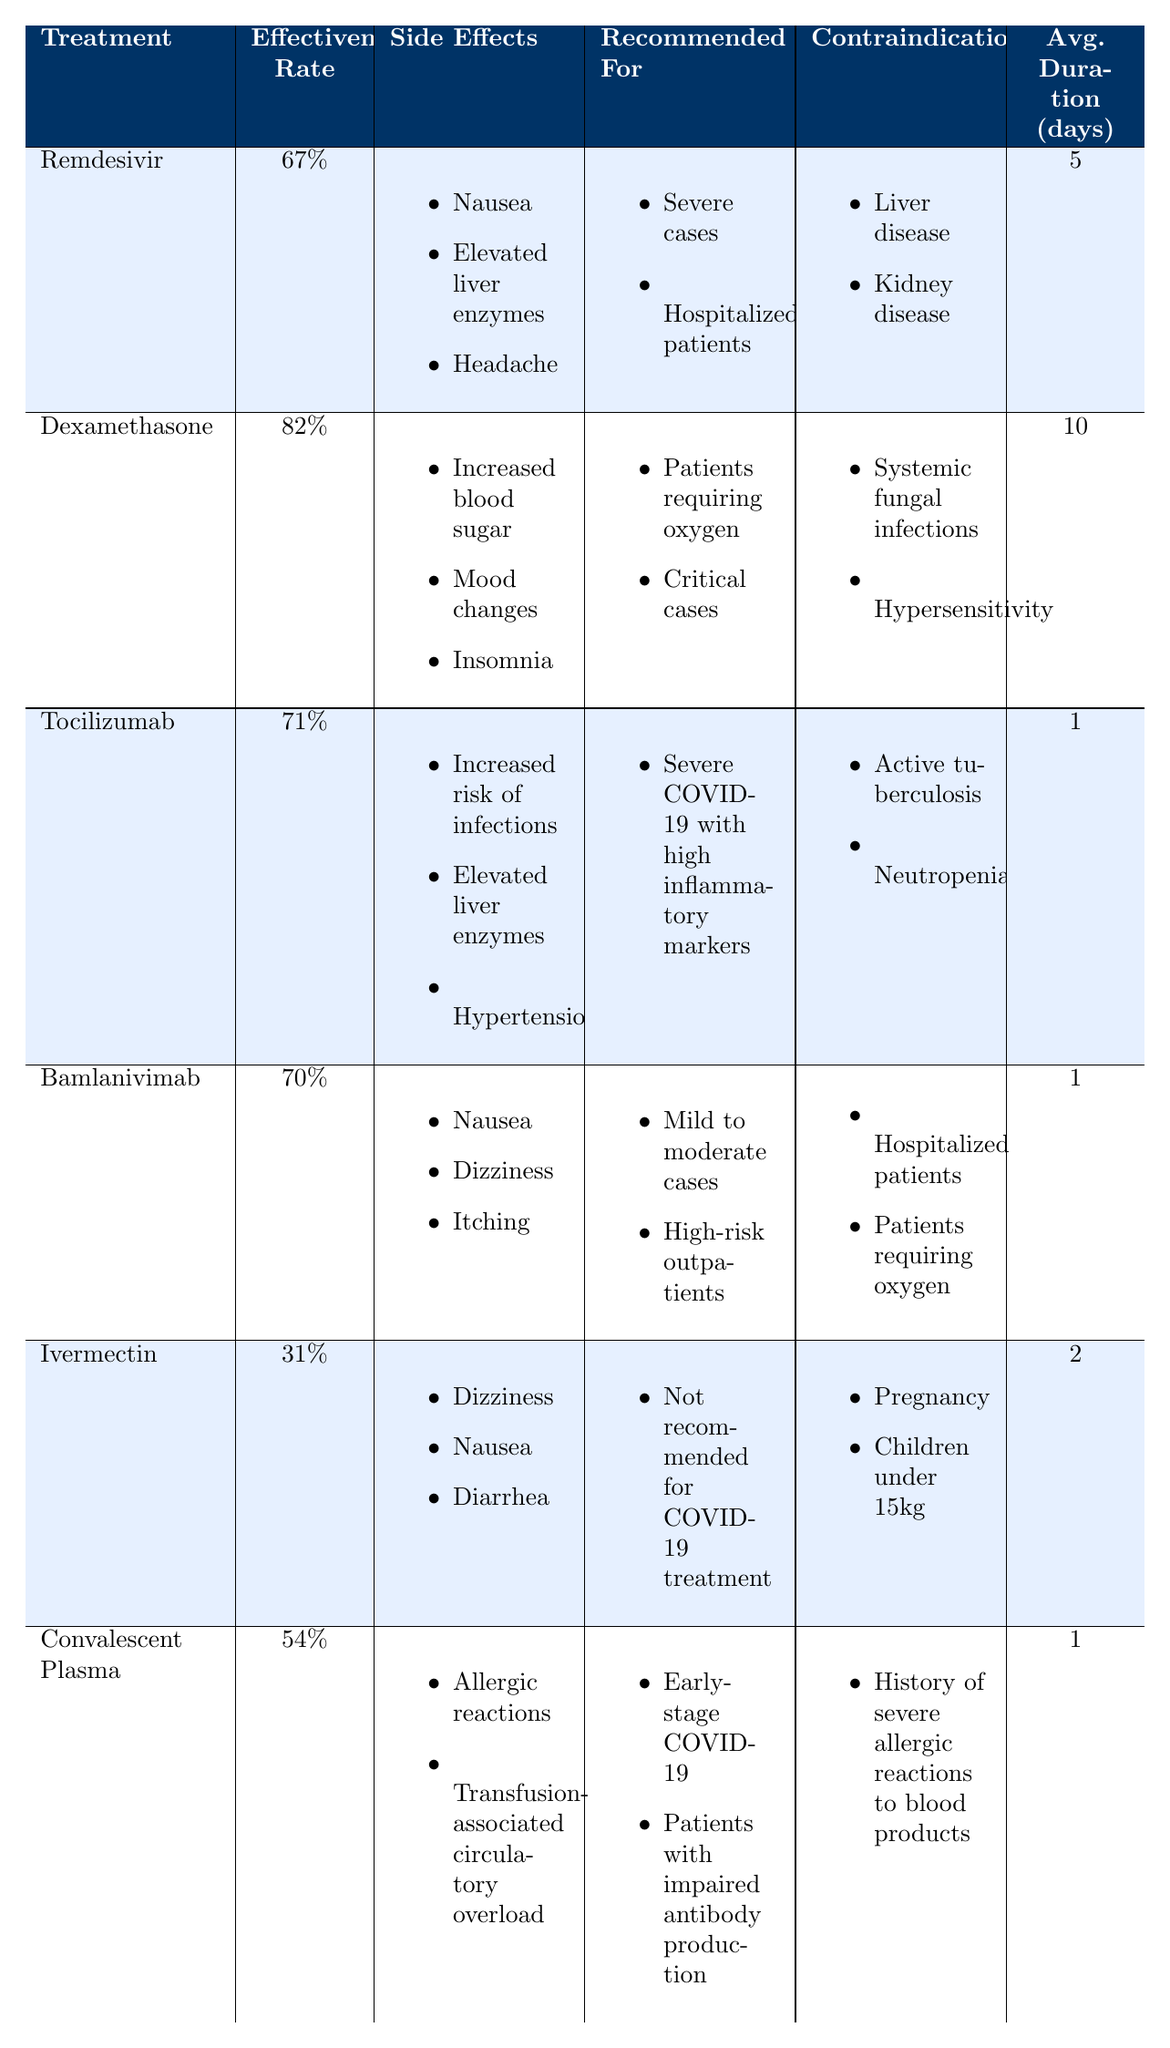What is the effectiveness rate of Dexamethasone? The table lists Dexamethasone with an effectiveness rate of 82%.
Answer: 82% Which treatment has the highest effectiveness rate? Dexamethasone has the highest effectiveness rate of 82% compared to the other treatments listed.
Answer: Dexamethasone Are there any contraindications for Remdesivir? Yes, the contraindications for Remdesivir are liver disease and kidney disease as shown in the table.
Answer: Yes How long is the average treatment duration for Tocilizumab? Tocilizumab has an average treatment duration of 1 day according to the table.
Answer: 1 day Which treatment is not recommended for COVID-19 treatment? The table indicates that Ivermectin is not recommended for COVID-19 treatment.
Answer: Ivermectin What side effects does Bamlanivimab cause? Bamlanivimab has side effects of nausea, dizziness, and itching as listed in the table.
Answer: Nausea, dizziness, itching How many treatments are recommended for severe cases? Two treatments are recommended for severe cases: Remdesivir and Tocilizumab.
Answer: 2 Is there a treatment recommended for mild to moderate cases? Yes, Bamlanivimab is recommended for mild to moderate cases.
Answer: Yes Which treatment has an effectiveness rate lower than 50%? Ivermectin has an effectiveness rate of 31%, which is lower than 50%.
Answer: Ivermectin What is the total average duration of treatment for the listed treatments? The average treatment durations are 5, 10, 1, 1, 2, and 1 days respectively. Sum them to get 20 days and divide by 6 treatments, giving an average of approximately 3.33 days.
Answer: 3.33 days 